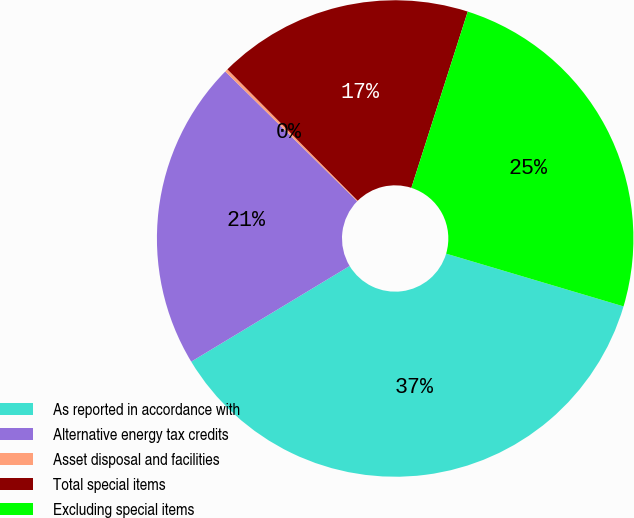Convert chart. <chart><loc_0><loc_0><loc_500><loc_500><pie_chart><fcel>As reported in accordance with<fcel>Alternative energy tax credits<fcel>Asset disposal and facilities<fcel>Total special items<fcel>Excluding special items<nl><fcel>36.75%<fcel>21.01%<fcel>0.2%<fcel>17.36%<fcel>24.67%<nl></chart> 